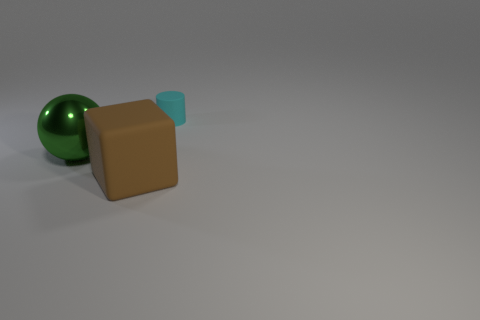Add 1 large matte blocks. How many objects exist? 4 Add 3 small things. How many small things are left? 4 Add 1 large green rubber blocks. How many large green rubber blocks exist? 1 Subtract 0 brown cylinders. How many objects are left? 3 Subtract all cylinders. How many objects are left? 2 Subtract all large gray shiny cubes. Subtract all green metallic spheres. How many objects are left? 2 